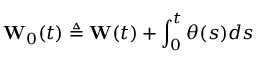Convert formula to latex. <formula><loc_0><loc_0><loc_500><loc_500>W _ { 0 } ( t ) \triangle q W ( t ) + \int _ { 0 } ^ { t } \theta ( s ) d s</formula> 